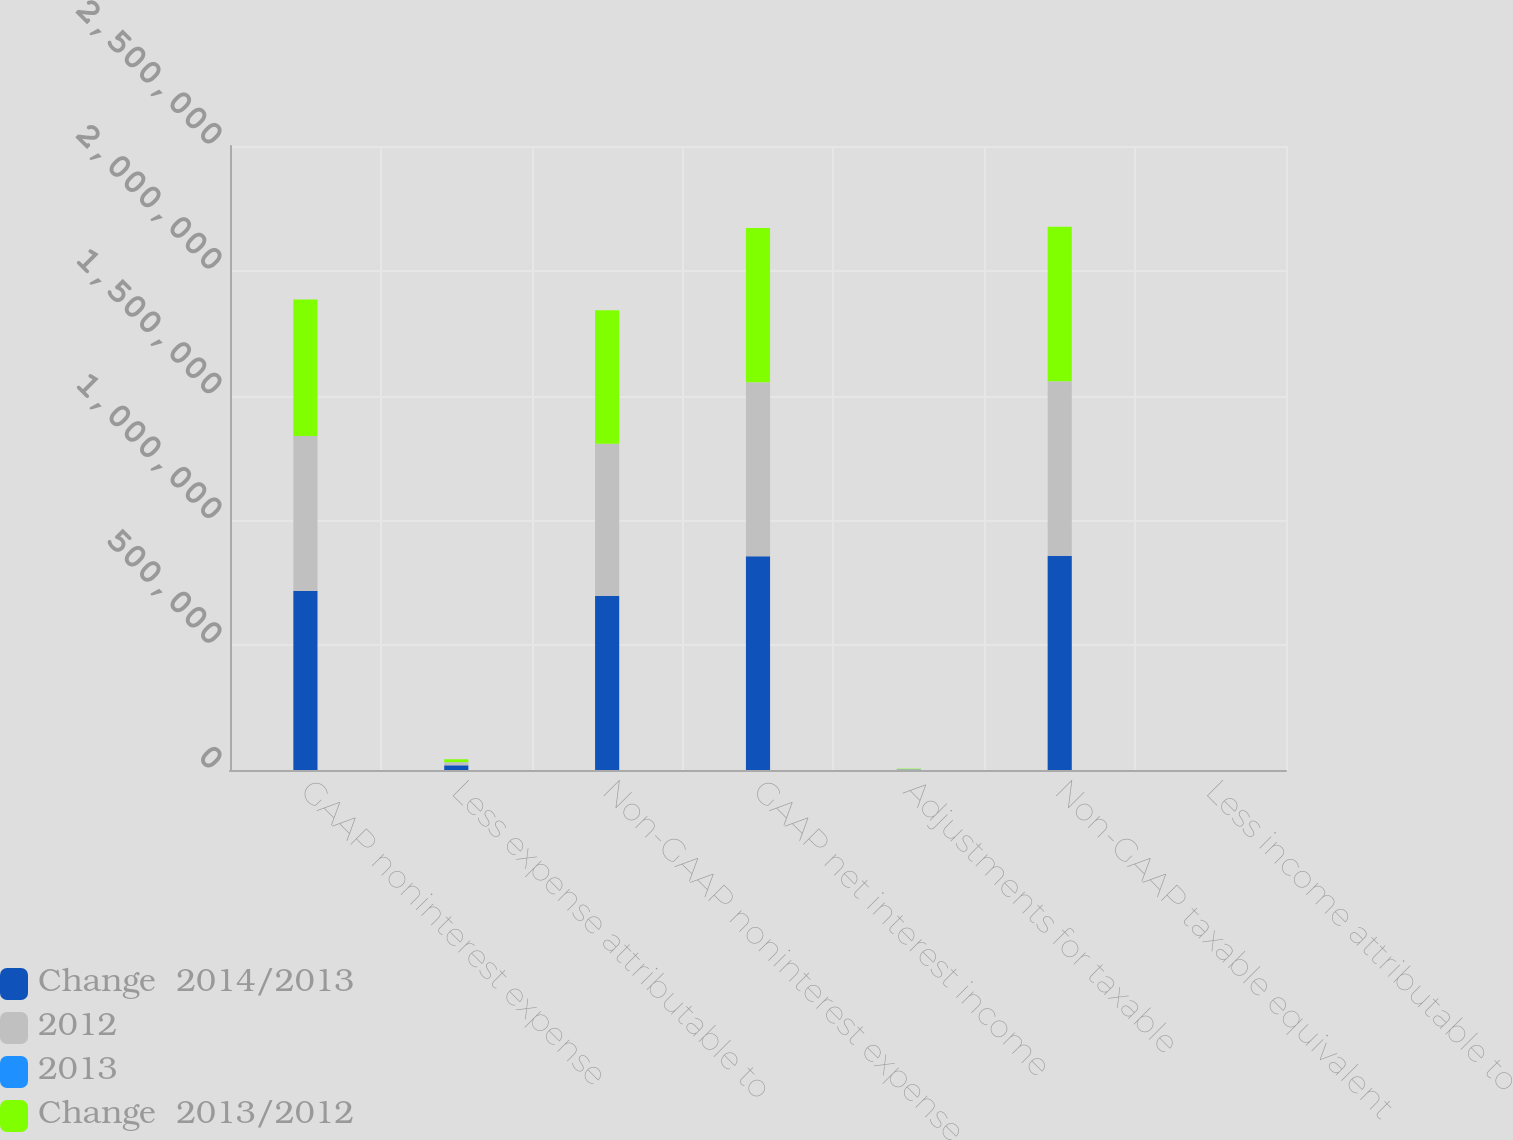<chart> <loc_0><loc_0><loc_500><loc_500><stacked_bar_chart><ecel><fcel>GAAP noninterest expense<fcel>Less expense attributable to<fcel>Non-GAAP noninterest expense<fcel>GAAP net interest income<fcel>Adjustments for taxable<fcel>Non-GAAP taxable equivalent<fcel>Less income attributable to<nl><fcel>Change  2014/2013<fcel>716871<fcel>18867<fcel>698004<fcel>856595<fcel>1689<fcel>858251<fcel>33<nl><fcel>2012<fcel>621680<fcel>12714<fcel>608966<fcel>697344<fcel>1724<fcel>698992<fcel>76<nl><fcel>2013<fcel>15.3<fcel>48.4<fcel>14.6<fcel>22.8<fcel>2<fcel>22.8<fcel>56.6<nl><fcel>Change  2013/2012<fcel>545998<fcel>11336<fcel>534662<fcel>617864<fcel>1919<fcel>619677<fcel>106<nl></chart> 